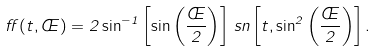Convert formula to latex. <formula><loc_0><loc_0><loc_500><loc_500>\alpha ( t , \phi ) = 2 \sin ^ { - 1 } \left [ \sin \left ( \frac { \phi } { 2 } \right ) \right ] \, s n \left [ t , \sin ^ { 2 } \left ( \frac { \phi } { 2 } \right ) \right ] .</formula> 